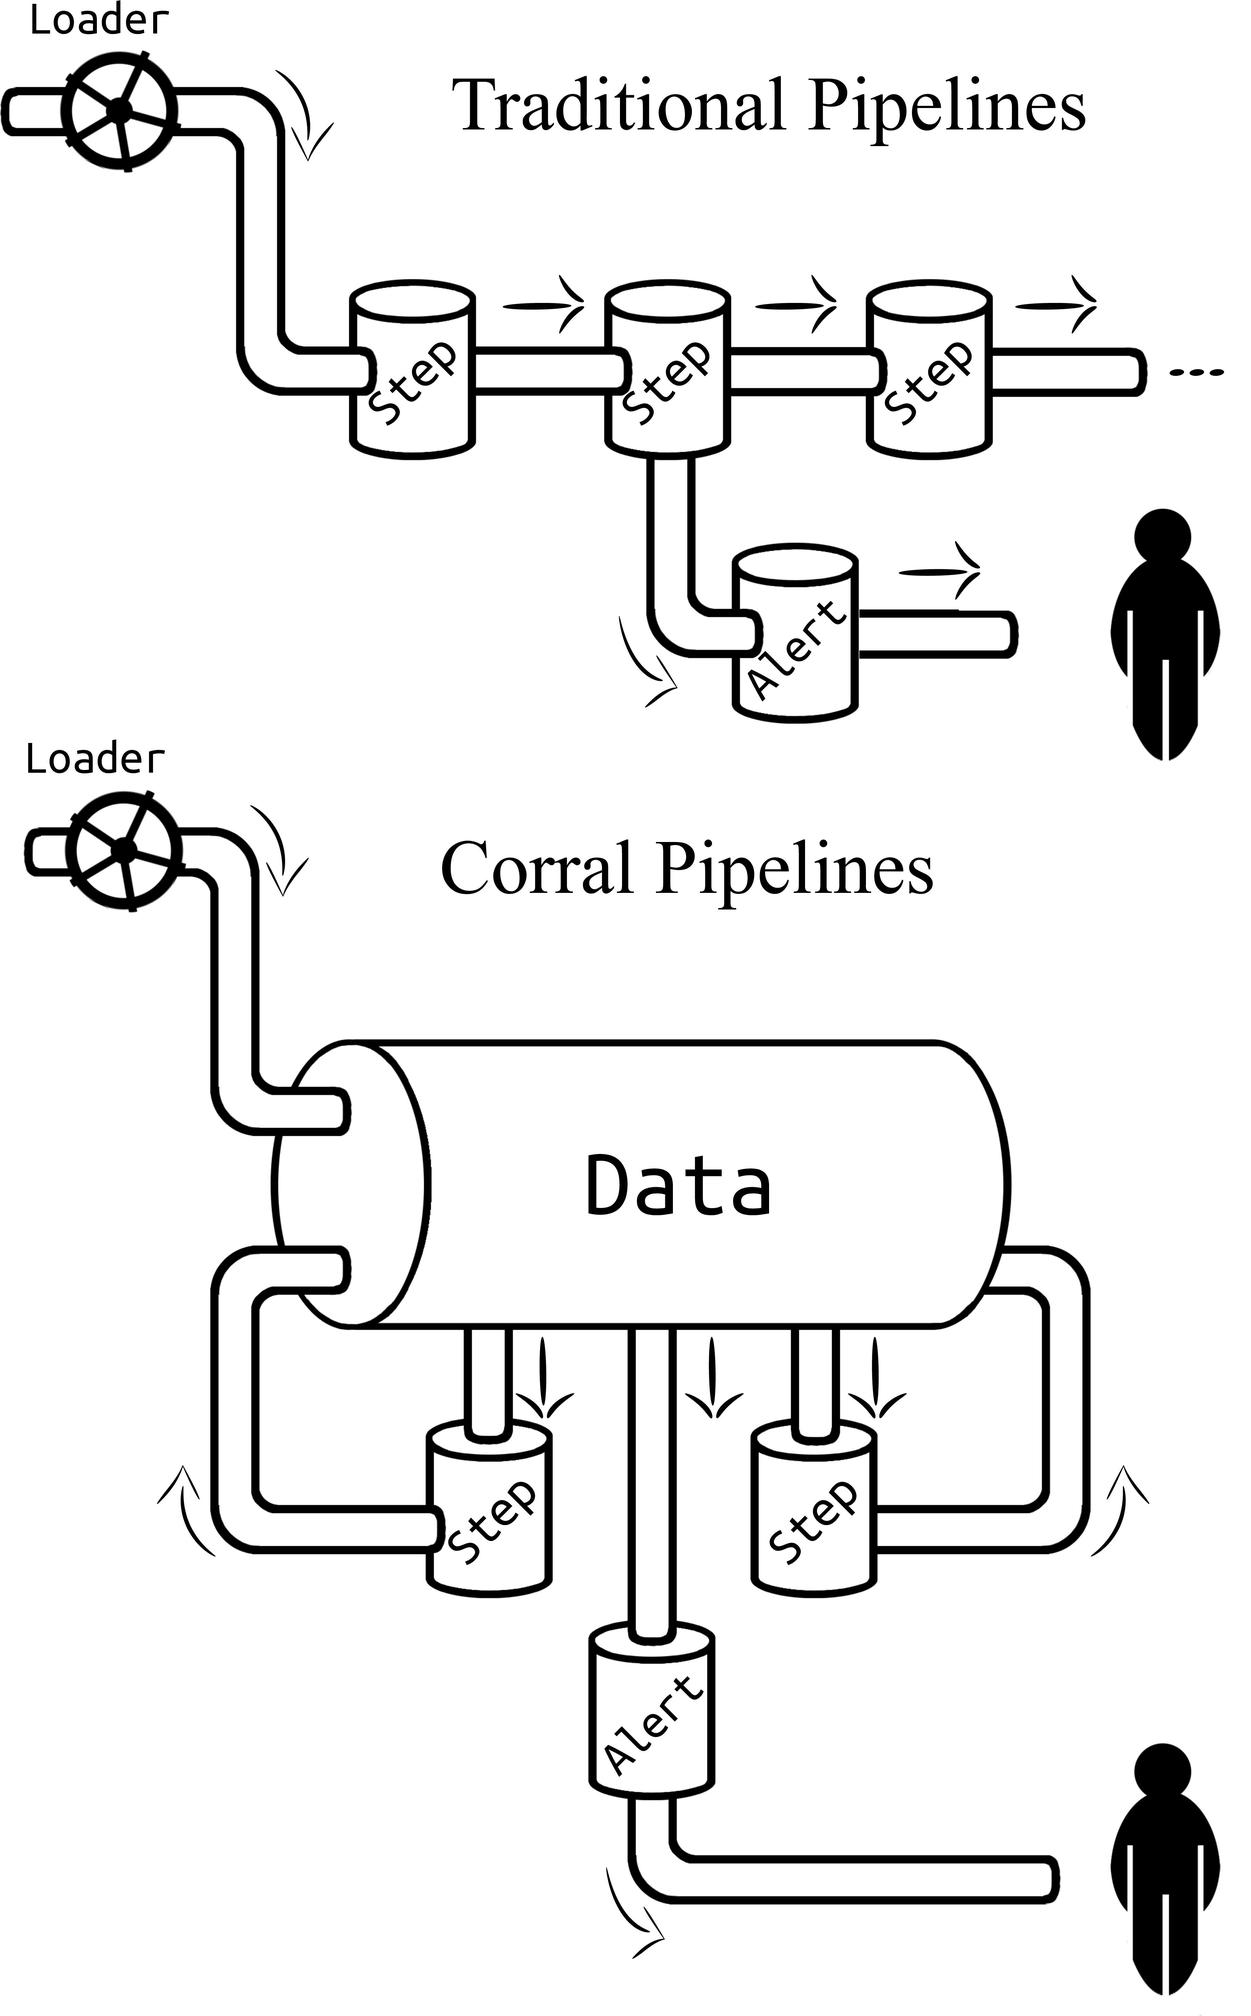Can you infer the potential benefit of using the 'Corral Pipelines' over the 'Traditional Pipelines' as shown in the image? Based on the image, the 'Corral Pipelines' appear to offer a more integrated and streamlined approach to data processing. By centralizing the data within a large container, this design could facilitate easier management and oversight of the entire process. This might lead to benefits such as improved error handling, as all alerts and issues can be managed within the same contextual framework, possibly making it simpler to trace and address problems. Moreover, a centralized system may enhance data throughput and efficiency, since it appears to minimize redundancy and streamline communication between different steps in the pipeline. 